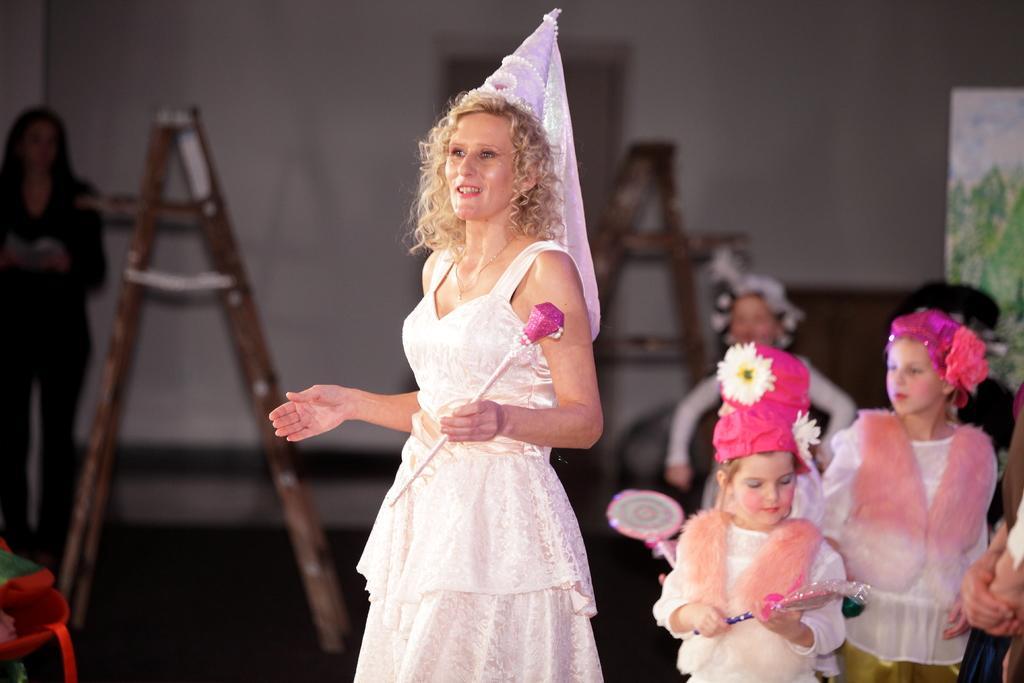Can you describe this image briefly? In the foreground of this image, there is a woman standing wearing white dress and holding a stick in her hand. In the background, there are kids standing wearing white dresses and pink caps, few ladders, a woman standing and the wall. 